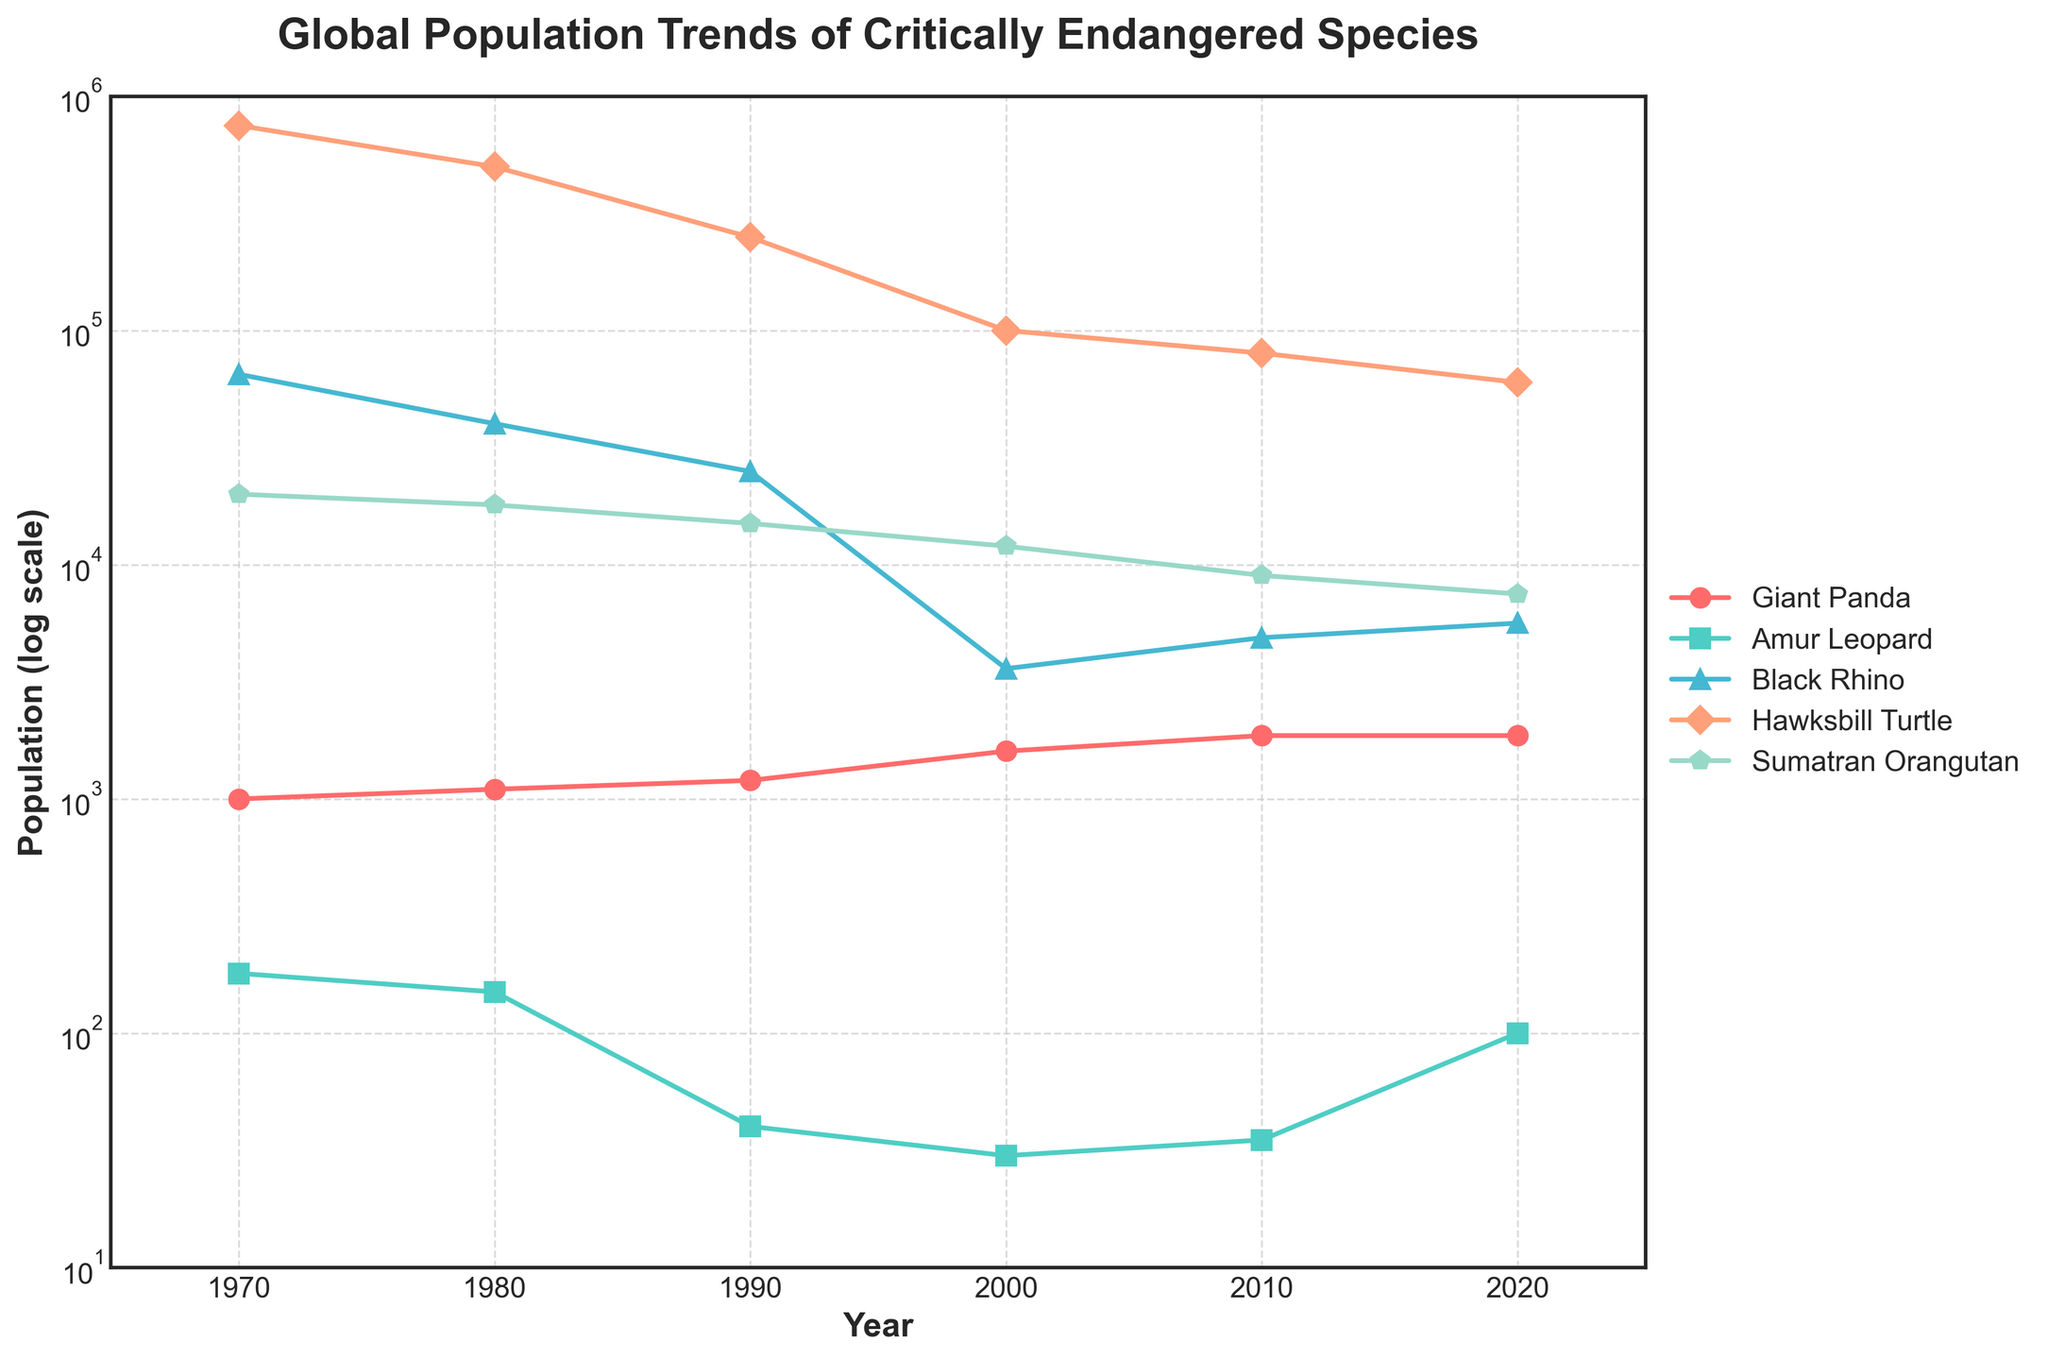What's the overall trend for the Giant Panda's population from 1970 to 2020? Observing the orange-red line representing the Giant Panda, the population increases steadily from 1000 individuals in 1970 to 1864 in 2020.
Answer: The overall trend is increasing Which species had the sharpest decline in population between 1970 and 1990? By comparing all species' populations between 1970 and 1990, the Amur Leopard's population decreases the most dramatically from 180 to 40.
Answer: Amur Leopard Which species show a population gain from 2010 to 2020? The lines representing the species with increased population from 2010 to 2020 can be identified. Both the Amur Leopard (35 to 100) and Black Rhino (4880 to 5630) show gains.
Answer: Amur Leopard, Black Rhino What year did the Black Rhino's population fall below 5000? The green line for Black Rhino crosses below the 5000 mark before 2000, specifically at 3600 in the year 2000.
Answer: 2000 Compare the Sumatran Orangutan's population in 1970 and 2020. What is the percentage decrease? In 1970, the population was 20000, and in 2020 it was 7500. The percentage decrease is calculated as ((20000 - 7500) / 20000) * 100 = 62.5%.
Answer: 62.5% Which species had the most stable population over the 50-year period? The flatness of the lines indicates stability. Observing the lines, the Giant Panda shows the most stable increase, indicating stability compared to others.
Answer: Giant Panda In which decade did the Hawksbill Turtle experience the largest drop in population? The purple line for Hawksbill Turtle shows the largest drop from 1970 to 1980, where it dropped from 750000 to 500000.
Answer: 1970-1980 What is the combined population of the Giant Panda and Black Rhino in 2020? The population of the Giant Panda in 2020 is 1864, and the Black Rhino is 5630. Their combined population is 1864 + 5630 = 7494.
Answer: 7494 Compare the lowest population of Amur Leopard and Black Rhino, which is lower? The lowest population of the Amur Leopard occurs in 2000 with 30 individuals, and for the Black Rhino in 2000 with 3600 individuals. Therefore, Amur Leopard has the lowest population.
Answer: Amur Leopard 